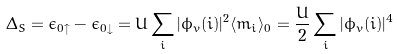Convert formula to latex. <formula><loc_0><loc_0><loc_500><loc_500>\Delta _ { S } = \epsilon _ { 0 \uparrow } - \epsilon _ { 0 \downarrow } = U \sum _ { i } | \phi _ { v } ( i ) | ^ { 2 } \langle m _ { i } \rangle _ { 0 } = \frac { U } { 2 } \sum _ { i } | \phi _ { v } ( i ) | ^ { 4 }</formula> 